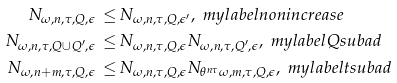<formula> <loc_0><loc_0><loc_500><loc_500>N _ { \omega , n , \tau , Q , \epsilon } \, \leq & \, N _ { \omega , n , \tau , Q , \epsilon ^ { \prime } } , \ m y l a b e l { n o n i n c r e a s e } \\ N _ { \omega , n , \tau , Q \cup Q ^ { \prime } , \epsilon } \, \leq & \, N _ { \omega , n , \tau , Q , \epsilon } N _ { \omega , n , \tau , Q ^ { \prime } , \epsilon } , \ m y l a b e l { Q s u b a d } \\ N _ { \omega , n + m , \tau , Q , \epsilon } \, \leq & \, N _ { \omega , n , \tau , Q , \epsilon } N _ { \theta ^ { n \tau } \omega , m , \tau , Q , \epsilon } , \ m y l a b e l { t s u b a d }</formula> 